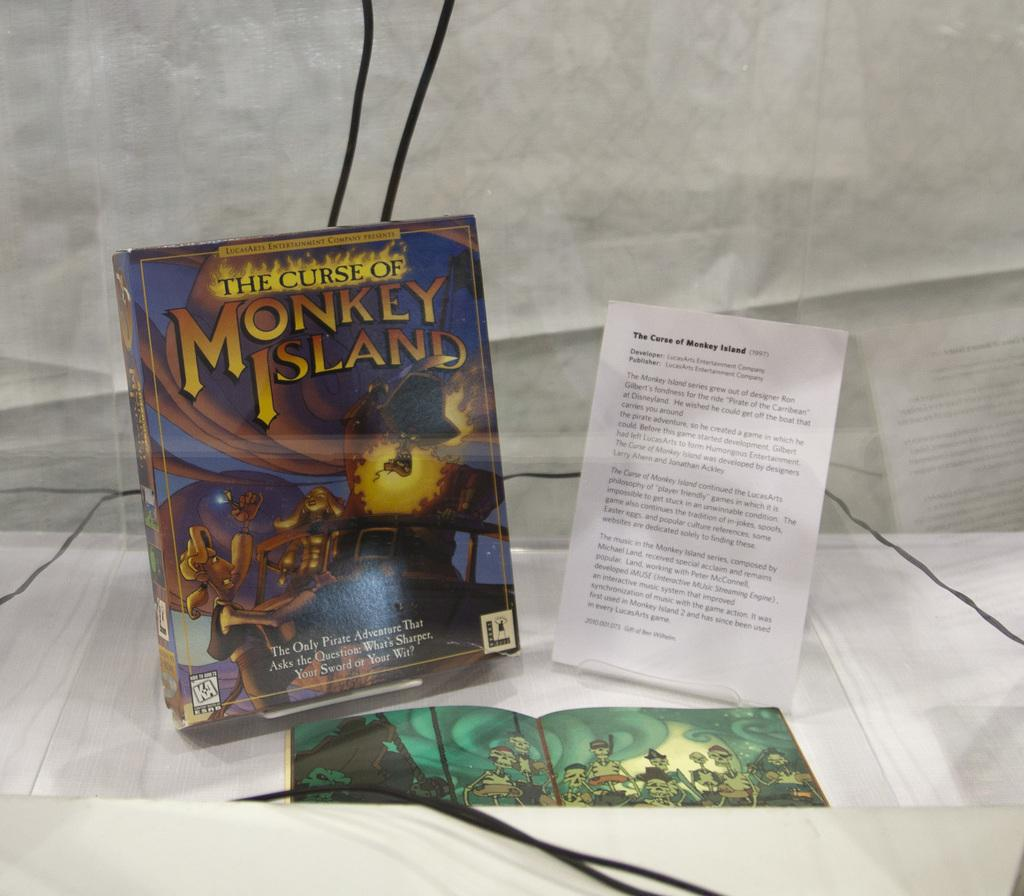<image>
Present a compact description of the photo's key features. a couple of books on a surface and one which says Monkey Island 